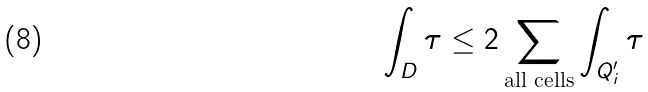<formula> <loc_0><loc_0><loc_500><loc_500>\int _ { D } \tau \leq 2 \sum _ { \text {all cells} } \int _ { Q _ { i } ^ { \prime } } \tau</formula> 